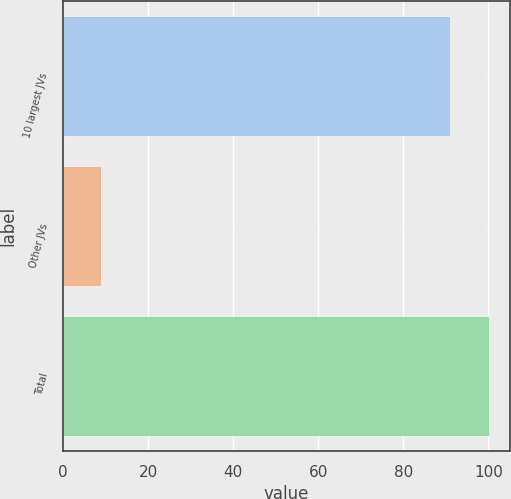Convert chart. <chart><loc_0><loc_0><loc_500><loc_500><bar_chart><fcel>10 largest JVs<fcel>Other JVs<fcel>Total<nl><fcel>91<fcel>9<fcel>100.1<nl></chart> 